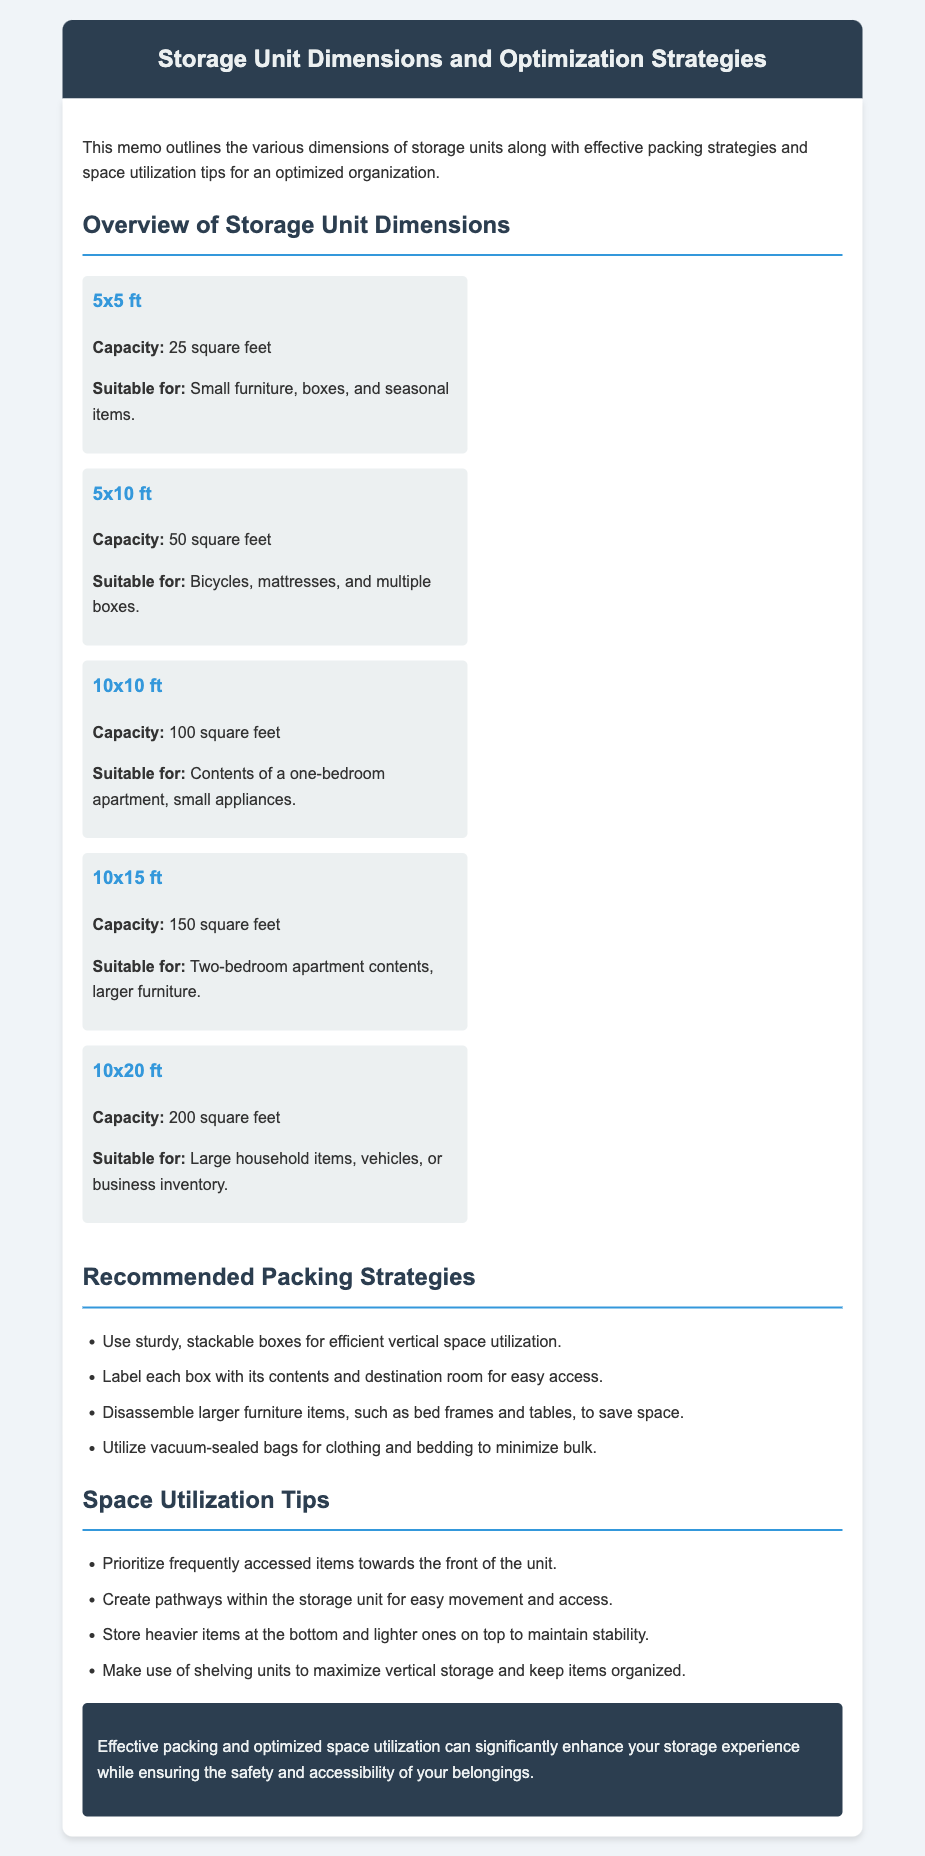What is the capacity of a 5x10 ft unit? The capacity is stated in square feet for each storage unit dimension. The 5x10 ft unit has a capacity of 50 square feet.
Answer: 50 square feet What items are suitable for a 10x20 ft unit? The document lists what types of items each storage unit size is suitable for. A 10x20 ft unit is suitable for large household items, vehicles, or business inventory.
Answer: Large household items, vehicles, or business inventory What packing strategy involves using bags? The packing strategy section suggests effective methods for packing and organization. It mentions utilizing vacuum-sealed bags for clothing and bedding to minimize bulk.
Answer: Vacuum-sealed bags How many storage unit dimensions are listed in total? The document provides an overview of several storage unit dimensions. There are five dimensions listed in the overview.
Answer: Five What should you prioritize towards the front of the storage unit? The space utilization tips section contains various suggestions for organizing items in the unit. It suggests prioritizing frequently accessed items towards the front of the unit.
Answer: Frequently accessed items What type of information does the conclusion provide? The conclusion section summarizes the benefits of effective packing and space utilization strategies discussed in the document. It addresses the overall enhancement of the storage experience.
Answer: Summary of benefits What is the recommended packing strategy for labeling boxes? The recommendations for packing include specific practices for organizing items in boxes. One strategy is to label each box with its contents and destination room for easy access.
Answer: Label each box What is a tip for maintaining stability in the storage unit? The space utilization tips suggest how to store items effectively. It states to store heavier items at the bottom and lighter ones on top to maintain stability.
Answer: Store heavier items at the bottom 